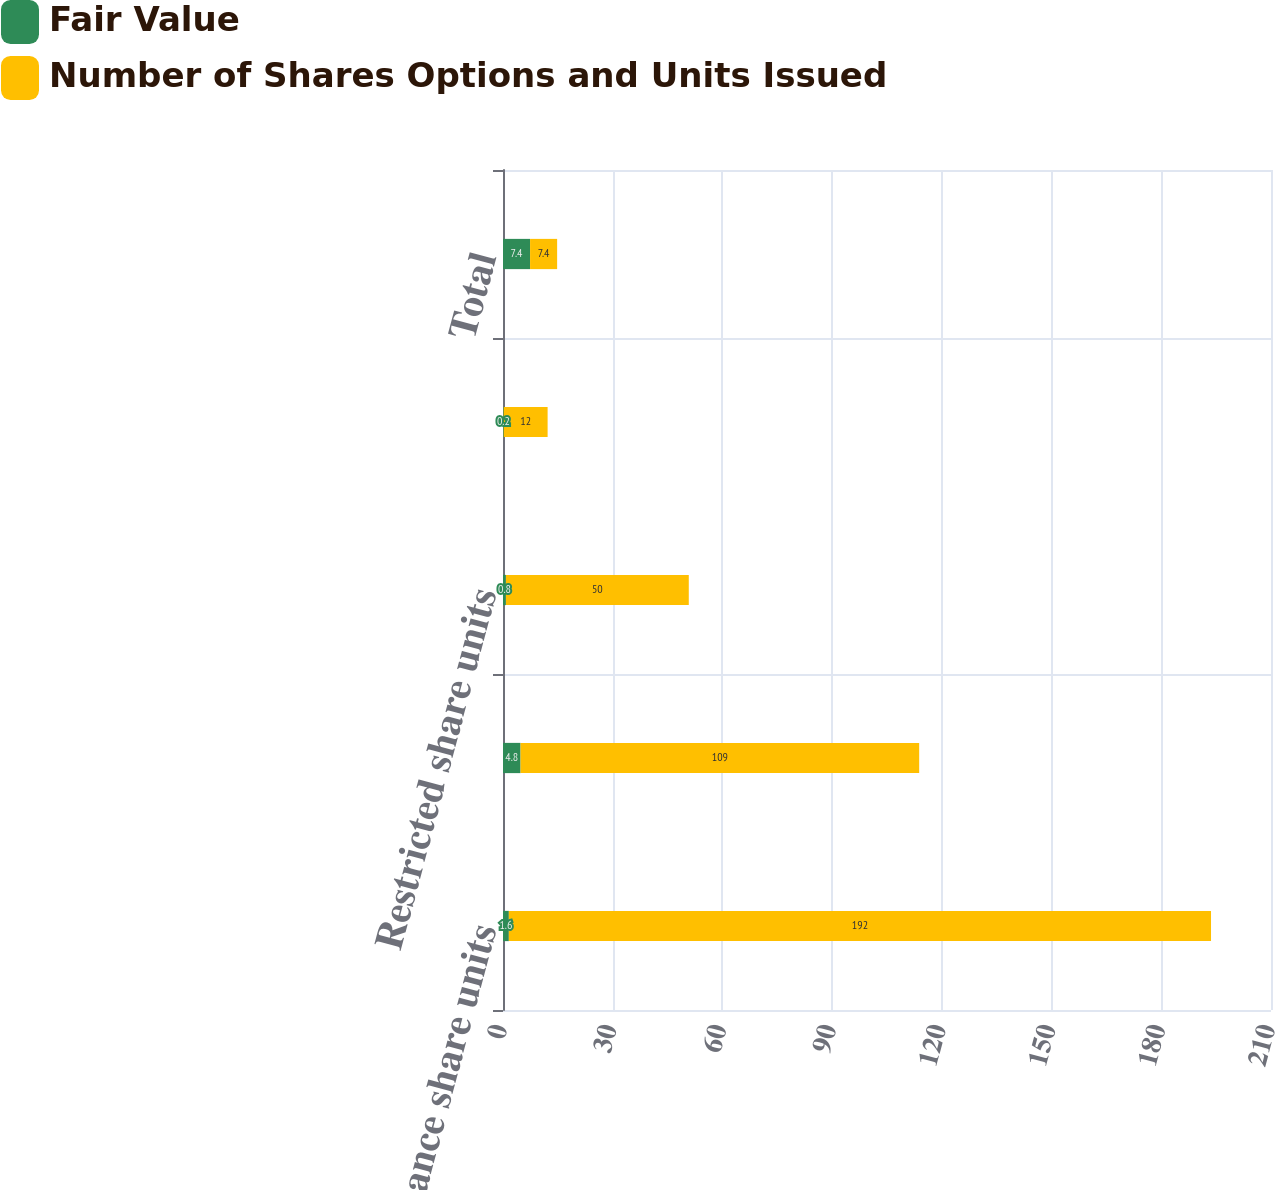Convert chart to OTSL. <chart><loc_0><loc_0><loc_500><loc_500><stacked_bar_chart><ecel><fcel>Performance share units<fcel>Stock options<fcel>Restricted share units<fcel>Restricted stock<fcel>Total<nl><fcel>Fair Value<fcel>1.6<fcel>4.8<fcel>0.8<fcel>0.2<fcel>7.4<nl><fcel>Number of Shares Options and Units Issued<fcel>192<fcel>109<fcel>50<fcel>12<fcel>7.4<nl></chart> 